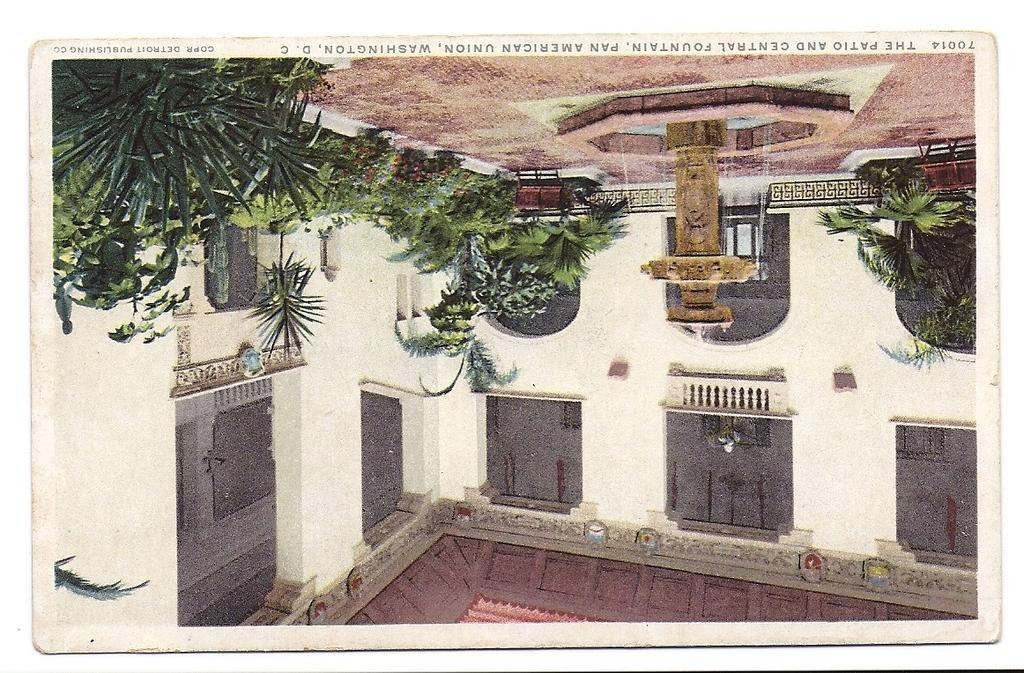What type of structures can be seen in the image? There are buildings in the image. What natural elements are present in the image? There are trees in the image. What type of water feature is visible in the image? There is a fountain in the image. What type of plants are present in the image? There are house plants in the image. What type of barrier is present in the image? There is a fence in the image. How is the image presented? The image appears to be a photo frame. What route is the dinner taking in the image? There is no dinner present in the image, so it's not possible to determine a route for it. 